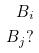<formula> <loc_0><loc_0><loc_500><loc_500>B _ { i } \\ B _ { j } ?</formula> 